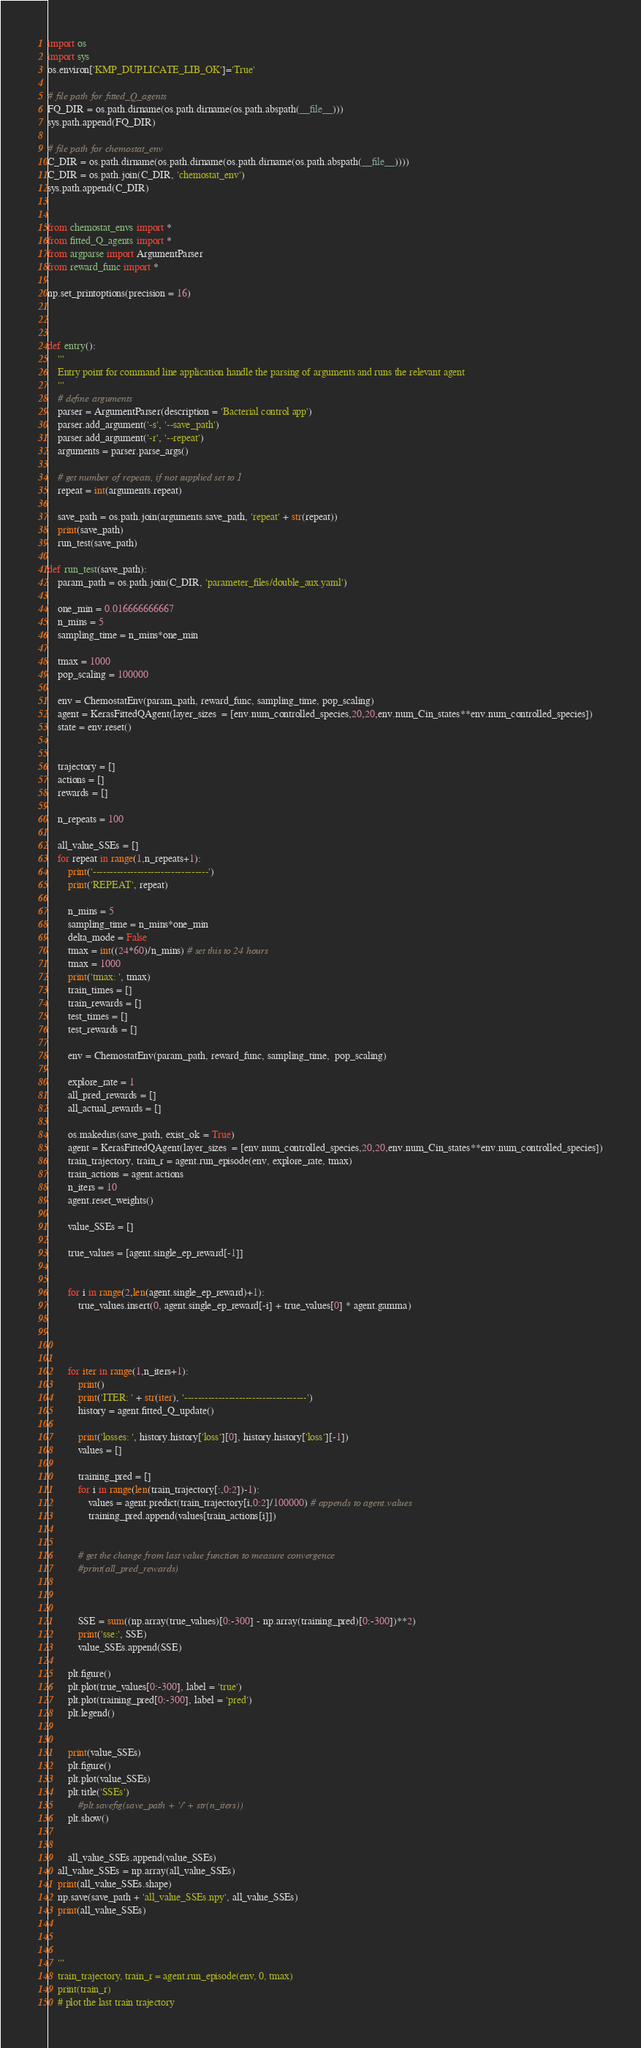<code> <loc_0><loc_0><loc_500><loc_500><_Python_>import os
import sys
os.environ['KMP_DUPLICATE_LIB_OK']='True'

# file path for fitted_Q_agents
FQ_DIR = os.path.dirname(os.path.dirname(os.path.abspath(__file__)))
sys.path.append(FQ_DIR)

# file path for chemostat_env
C_DIR = os.path.dirname(os.path.dirname(os.path.dirname(os.path.abspath(__file__))))
C_DIR = os.path.join(C_DIR, 'chemostat_env')
sys.path.append(C_DIR)


from chemostat_envs import *
from fitted_Q_agents import *
from argparse import ArgumentParser
from reward_func import *

np.set_printoptions(precision = 16)



def entry():
    '''
    Entry point for command line application handle the parsing of arguments and runs the relevant agent
    '''
    # define arguments
    parser = ArgumentParser(description = 'Bacterial control app')
    parser.add_argument('-s', '--save_path')
    parser.add_argument('-r', '--repeat')
    arguments = parser.parse_args()

    # get number of repeats, if not supplied set to 1
    repeat = int(arguments.repeat)

    save_path = os.path.join(arguments.save_path, 'repeat' + str(repeat))
    print(save_path)
    run_test(save_path)

def run_test(save_path):
    param_path = os.path.join(C_DIR, 'parameter_files/double_aux.yaml')

    one_min = 0.016666666667
    n_mins = 5
    sampling_time = n_mins*one_min

    tmax = 1000
    pop_scaling = 100000

    env = ChemostatEnv(param_path, reward_func, sampling_time, pop_scaling)
    agent = KerasFittedQAgent(layer_sizes  = [env.num_controlled_species,20,20,env.num_Cin_states**env.num_controlled_species])
    state = env.reset()


    trajectory = []
    actions = []
    rewards = []

    n_repeats = 100

    all_value_SSEs = []
    for repeat in range(1,n_repeats+1):
        print('----------------------------------')
        print('REPEAT', repeat)

        n_mins = 5
        sampling_time = n_mins*one_min
        delta_mode = False
        tmax = int((24*60)/n_mins) # set this to 24 hours
        tmax = 1000
        print('tmax: ', tmax)
        train_times = []
        train_rewards = []
        test_times = []
        test_rewards = []

        env = ChemostatEnv(param_path, reward_func, sampling_time,  pop_scaling)

        explore_rate = 1
        all_pred_rewards = []
        all_actual_rewards = []

        os.makedirs(save_path, exist_ok = True)
        agent = KerasFittedQAgent(layer_sizes  = [env.num_controlled_species,20,20,env.num_Cin_states**env.num_controlled_species])
        train_trajectory, train_r = agent.run_episode(env, explore_rate, tmax)
        train_actions = agent.actions
        n_iters = 10
        agent.reset_weights()

        value_SSEs = []

        true_values = [agent.single_ep_reward[-1]]


        for i in range(2,len(agent.single_ep_reward)+1):
            true_values.insert(0, agent.single_ep_reward[-i] + true_values[0] * agent.gamma)




        for iter in range(1,n_iters+1):
            print()
            print('ITER: ' + str(iter), '------------------------------------')
            history = agent.fitted_Q_update()

            print('losses: ', history.history['loss'][0], history.history['loss'][-1])
            values = []

            training_pred = []
            for i in range(len(train_trajectory[:,0:2])-1):
                values = agent.predict(train_trajectory[i,0:2]/100000) # appends to agent.values
                training_pred.append(values[train_actions[i]])


            # get the change from last value function to measure convergence
            #print(all_pred_rewards)



            SSE = sum((np.array(true_values)[0:-300] - np.array(training_pred)[0:-300])**2)
            print('sse:', SSE)
            value_SSEs.append(SSE)

        plt.figure()
        plt.plot(true_values[0:-300], label = 'true')
        plt.plot(training_pred[0:-300], label = 'pred')
        plt.legend()


        print(value_SSEs)
        plt.figure()
        plt.plot(value_SSEs)
        plt.title('SSEs')
            #plt.savefig(save_path + '/' + str(n_iters))
        plt.show()


        all_value_SSEs.append(value_SSEs)
    all_value_SSEs = np.array(all_value_SSEs)
    print(all_value_SSEs.shape)
    np.save(save_path + 'all_value_SSEs.npy', all_value_SSEs)
    print(all_value_SSEs)



    '''
    train_trajectory, train_r = agent.run_episode(env, 0, tmax)
    print(train_r)
    # plot the last train trajectory</code> 